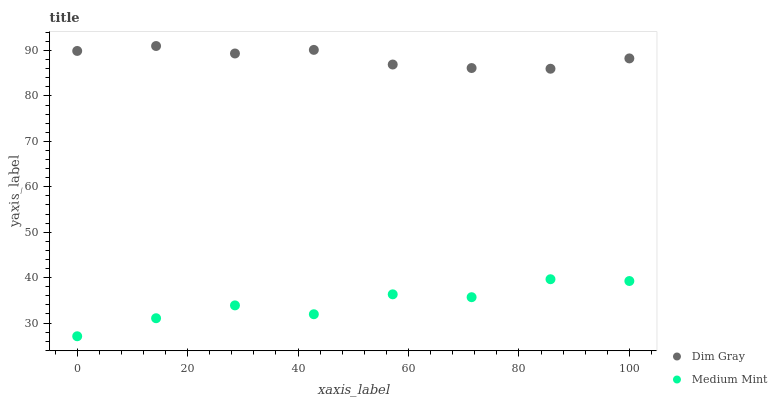Does Medium Mint have the minimum area under the curve?
Answer yes or no. Yes. Does Dim Gray have the maximum area under the curve?
Answer yes or no. Yes. Does Dim Gray have the minimum area under the curve?
Answer yes or no. No. Is Dim Gray the smoothest?
Answer yes or no. Yes. Is Medium Mint the roughest?
Answer yes or no. Yes. Is Dim Gray the roughest?
Answer yes or no. No. Does Medium Mint have the lowest value?
Answer yes or no. Yes. Does Dim Gray have the lowest value?
Answer yes or no. No. Does Dim Gray have the highest value?
Answer yes or no. Yes. Is Medium Mint less than Dim Gray?
Answer yes or no. Yes. Is Dim Gray greater than Medium Mint?
Answer yes or no. Yes. Does Medium Mint intersect Dim Gray?
Answer yes or no. No. 